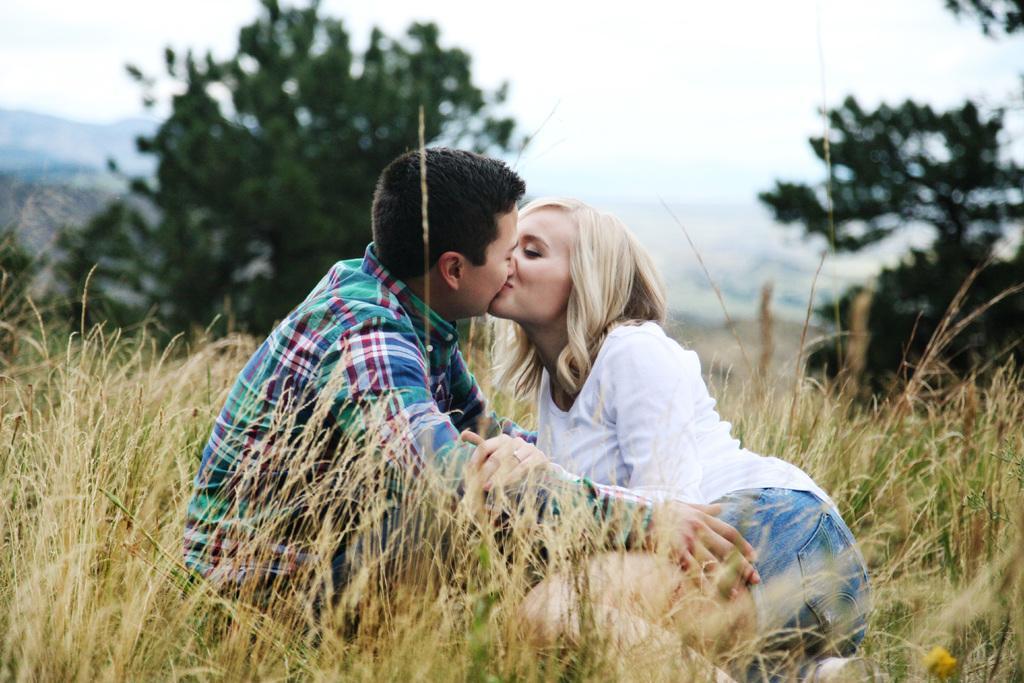In one or two sentences, can you explain what this image depicts? In the image in the center we can see two people were sitting and they were kissing. In the background we can see the sky,clouds,trees,plants and grass. 